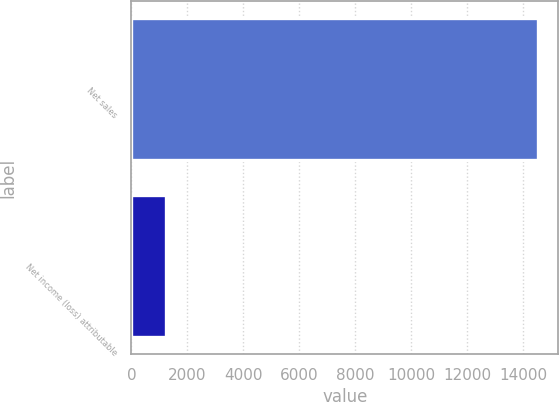Convert chart to OTSL. <chart><loc_0><loc_0><loc_500><loc_500><bar_chart><fcel>Net sales<fcel>Net income (loss) attributable<nl><fcel>14523<fcel>1244<nl></chart> 